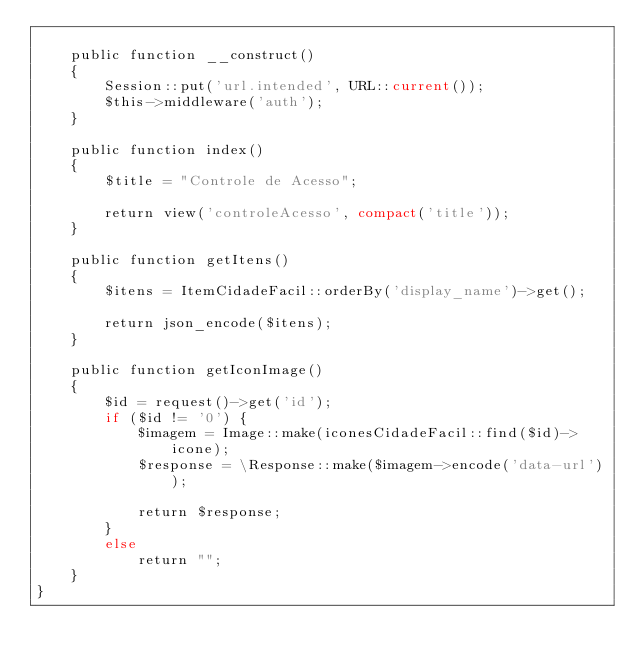Convert code to text. <code><loc_0><loc_0><loc_500><loc_500><_PHP_>
    public function __construct()
    {
        Session::put('url.intended', URL::current());
        $this->middleware('auth');
    }

    public function index()
    {
        $title = "Controle de Acesso";

        return view('controleAcesso', compact('title'));
    }

    public function getItens()
    {
        $itens = ItemCidadeFacil::orderBy('display_name')->get();

        return json_encode($itens);
    }

    public function getIconImage()
    {
        $id = request()->get('id');
        if ($id != '0') {
            $imagem = Image::make(iconesCidadeFacil::find($id)->icone);
            $response = \Response::make($imagem->encode('data-url'));

            return $response;
        }
        else
            return "";
    }
}
</code> 